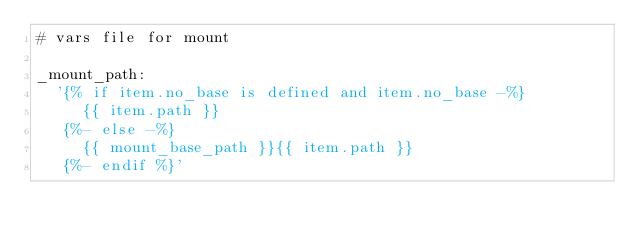<code> <loc_0><loc_0><loc_500><loc_500><_YAML_># vars file for mount

_mount_path:
  '{% if item.no_base is defined and item.no_base -%}
     {{ item.path }}
   {%- else -%}
     {{ mount_base_path }}{{ item.path }}
   {%- endif %}'
</code> 